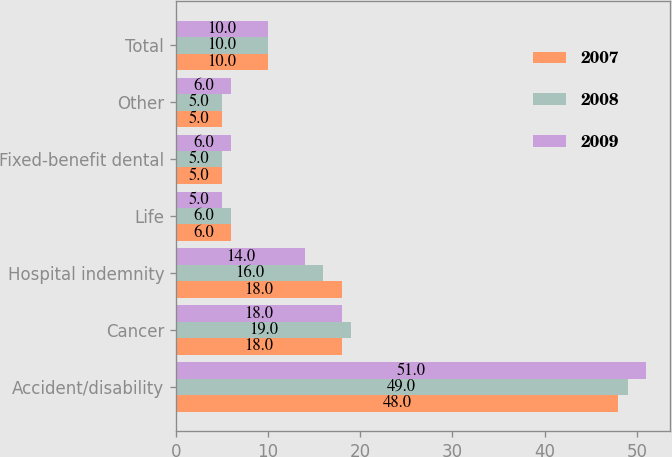<chart> <loc_0><loc_0><loc_500><loc_500><stacked_bar_chart><ecel><fcel>Accident/disability<fcel>Cancer<fcel>Hospital indemnity<fcel>Life<fcel>Fixed-benefit dental<fcel>Other<fcel>Total<nl><fcel>2007<fcel>48<fcel>18<fcel>18<fcel>6<fcel>5<fcel>5<fcel>10<nl><fcel>2008<fcel>49<fcel>19<fcel>16<fcel>6<fcel>5<fcel>5<fcel>10<nl><fcel>2009<fcel>51<fcel>18<fcel>14<fcel>5<fcel>6<fcel>6<fcel>10<nl></chart> 